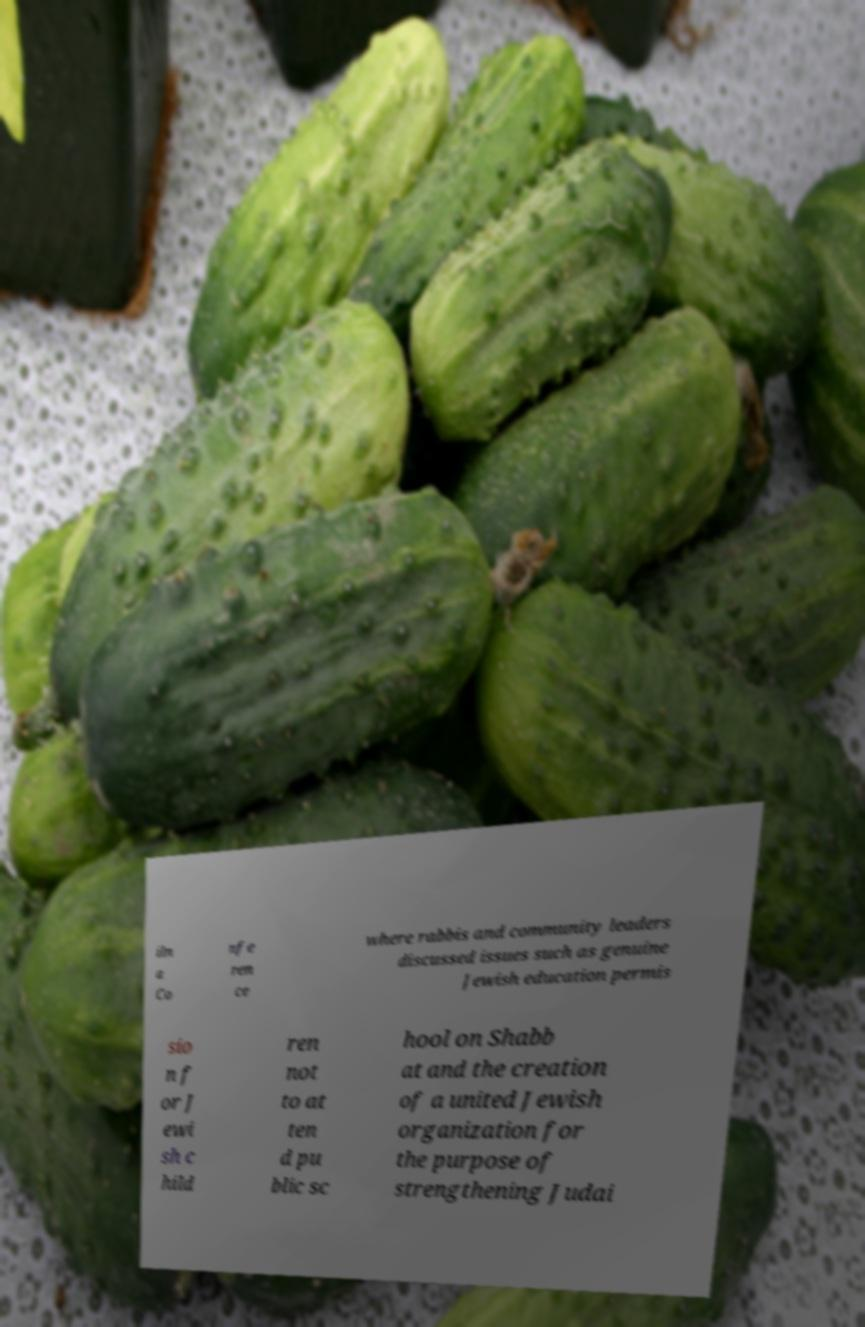I need the written content from this picture converted into text. Can you do that? iln a Co nfe ren ce where rabbis and community leaders discussed issues such as genuine Jewish education permis sio n f or J ewi sh c hild ren not to at ten d pu blic sc hool on Shabb at and the creation of a united Jewish organization for the purpose of strengthening Judai 